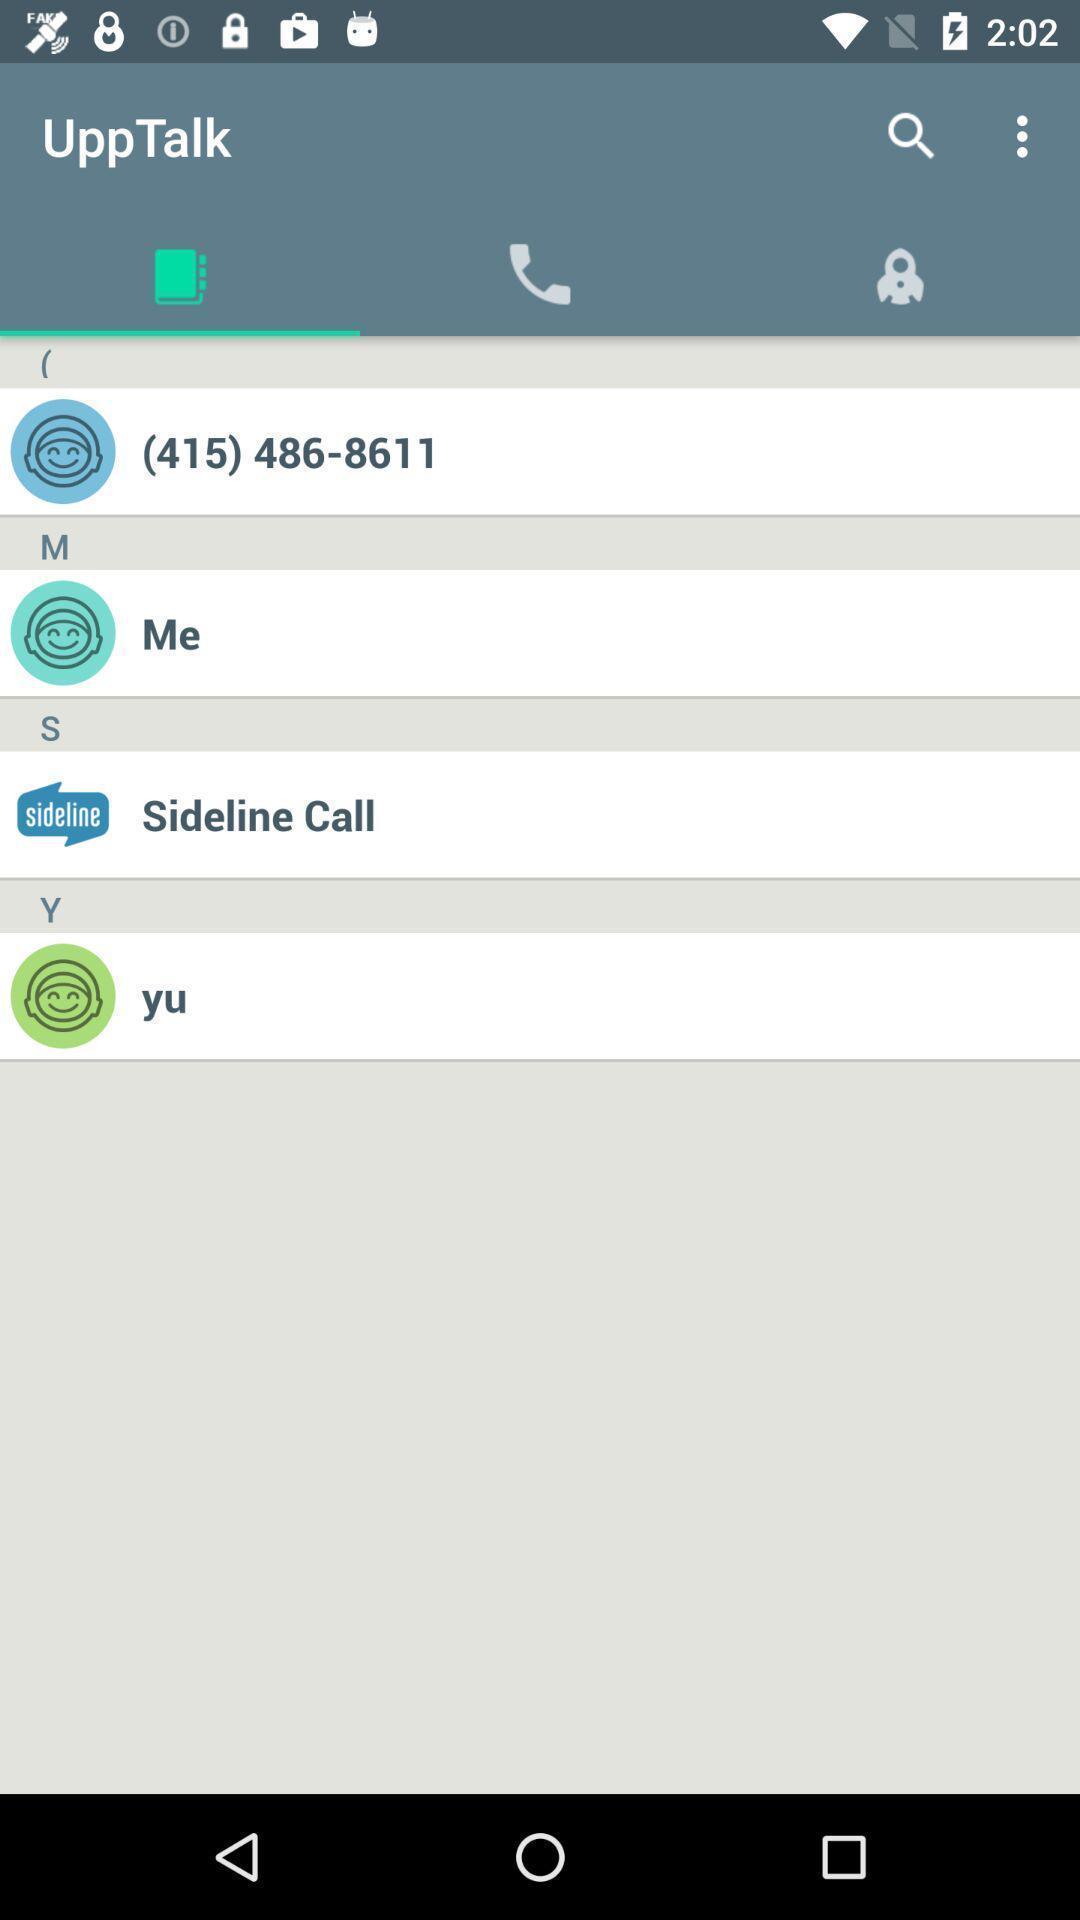Summarize the main components in this picture. Upptalk contact info in the app. 